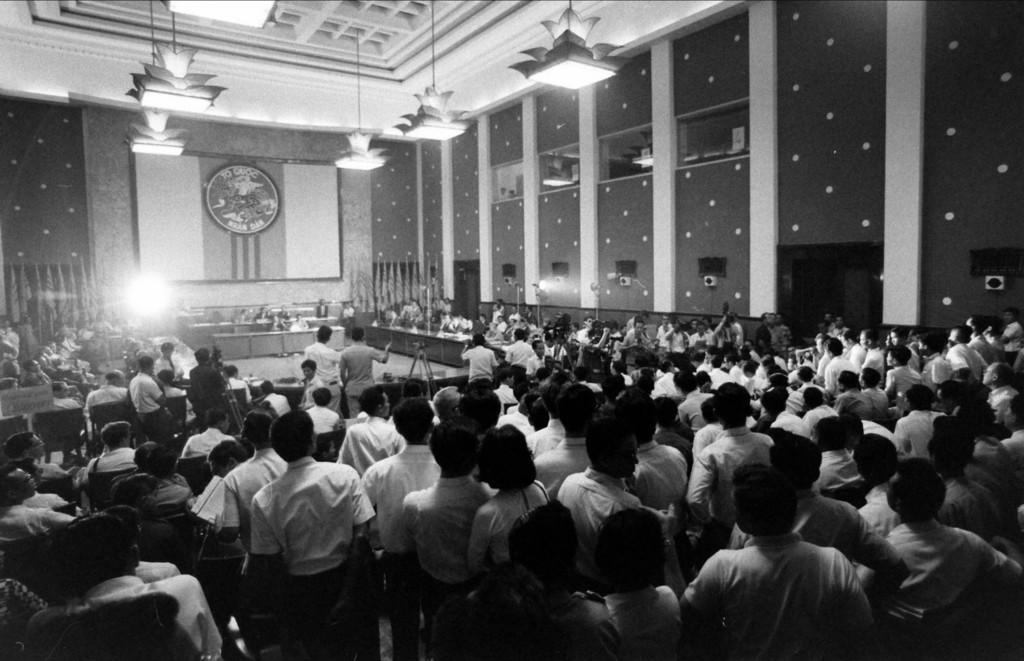How would you summarize this image in a sentence or two? In this image we can see some people standing and some are sitting in the chairs. We can see the pillars and hanging lights. We can see the ceiling and speakers. 